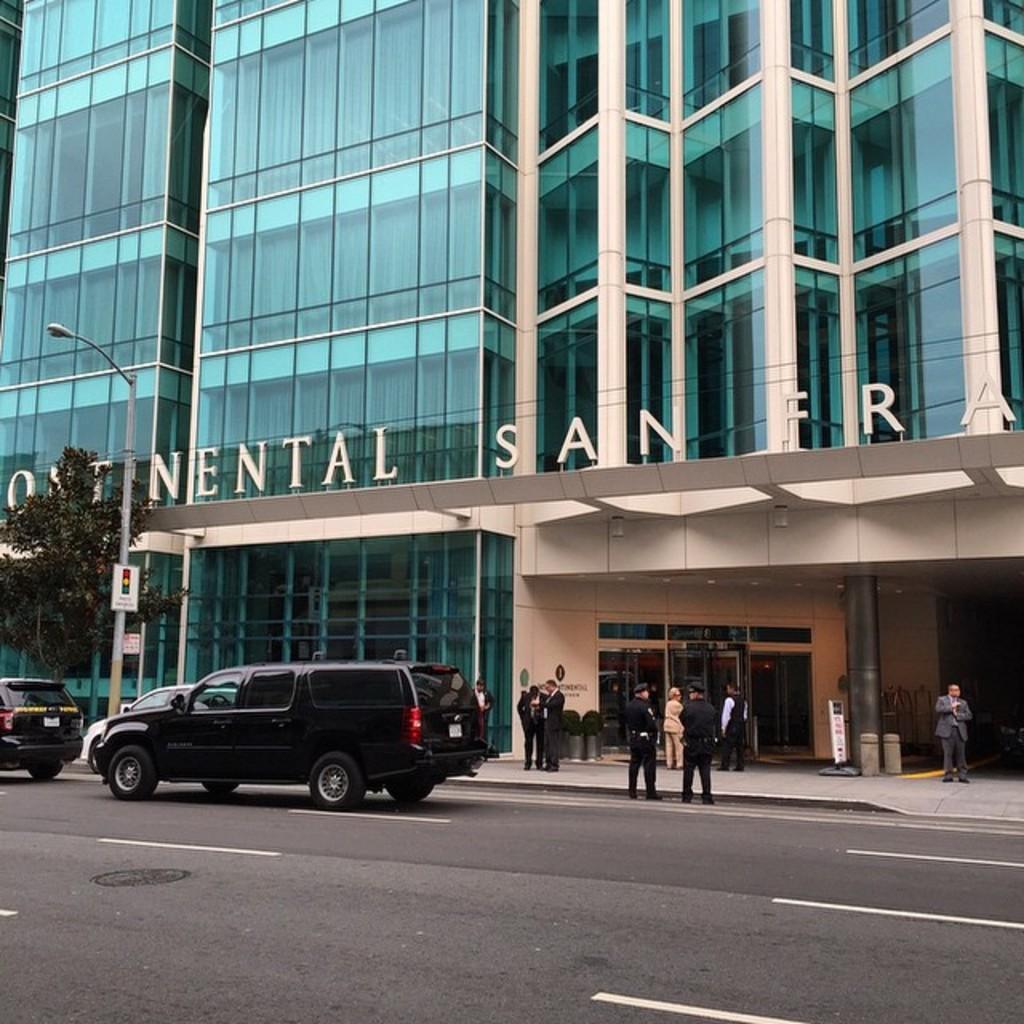In one or two sentences, can you explain what this image depicts? In this picture, we can see a few people, road, vehicles, poles, lights, trees, posters, building with doors, and some text on it. 